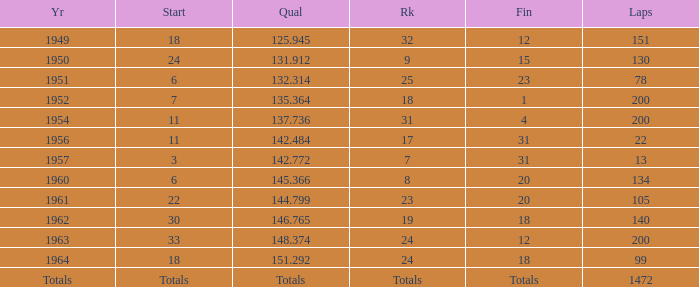What is the year with 200 circuits and a rank of 24? 1963.0. 